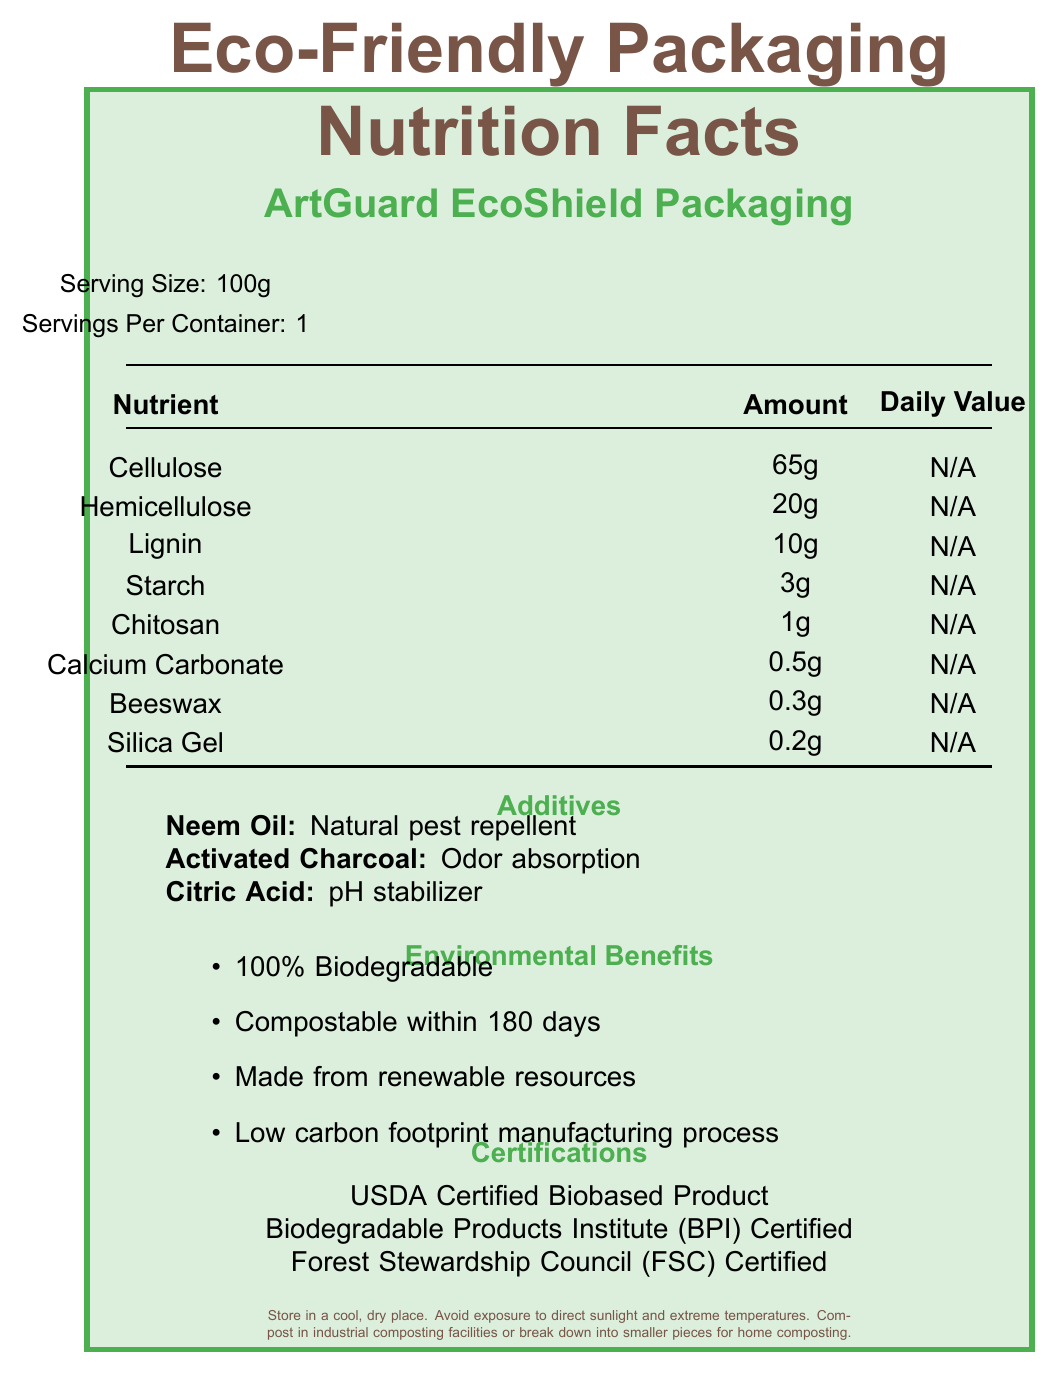what is the serving size for ArtGuard EcoShield Packaging? At the top of the document, under the product name, it states "Serving Size: 100g".
Answer: 100g how many grams of Chitosan are in one serving? Under the nutritional section, it lists "Chitosan" and indicates the amount as "1g".
Answer: 1g what are the primary materials listed in the nutrients section? The nutrients section lists these components with their respective amounts.
Answer: Cellulose, Hemicellulose, Lignin, Starch, Chitosan, Calcium Carbonate, Beeswax, Silica Gel what is the purpose of Neem Oil in the packaging? In the additives section, it states "Neem Oil" and describes its purpose as "Natural pest repellent".
Answer: Natural pest repellent what certifications does the packaging have? The certifications are listed towards the bottom of the document.
Answer: USDA Certified Biobased Product, Biodegradable Products Institute (BPI) Certified, Forest Stewardship Council (FSC) Certified which additive is used for odor absorption? The additives section lists "Activated Charcoal" with the purpose of "Odor absorption".
Answer: Activated Charcoal what is the correct amount of Silica Gel in the packaging? A. 0.1g B. 0.2g C. 0.3g D. 0.4g The nutritional section indicates that the amount of Silica Gel is "0.2g".
Answer: B. 0.2g what are the environmental benefits of the packaging? A. 100% Biodegradable, Compostable within 90 days, Made from recycled resources B. 100% Biodegradable, Compostable within 180 days, Made from renewable resources C. Compostable within 120 days, Made from renewable resources, Low carbon footprint manufacturing process D. 100% Biodegradable, Compostable within 180 days, Made from renewable resources, Low carbon footprint manufacturing process The Environmental Benefits section provides this information.
Answer: D. 100% Biodegradable, Compostable within 180 days, Made from renewable resources, Low carbon footprint manufacturing process is the packaging certified by the Forest Stewardship Council (FSC)? The certifications list includes the Forest Stewardship Council (FSC) Certified.
Answer: Yes describe the main idea of the document The description includes details about the packaging's nutrient composition, additives, environmental benefits, certifications, artifact protection features, and storage/disposal guidelines.
Answer: The document provides detailed nutritional facts about the ArtGuard EcoShield Packaging, highlighting its nutrient composition, additives, environmental benefits, and certifications. It focuses on the eco-friendly and biodegradable nature of the packaging, its artifact protection features, and proper storage and disposal instructions. what is the carbon footprint of the packaging's manufacturing process? The document mentions that the manufacturing process has a low carbon footprint but does not provide specific information or metrics to quantify it.
Answer: Cannot be determined how should the packaging be disposed of? At the bottom of the document, it provides disposal instructions, recommending composting in industrial facilities or breaking down for home composting.
Answer: Compost in industrial composting facilities or break down into smaller pieces for home composting. 